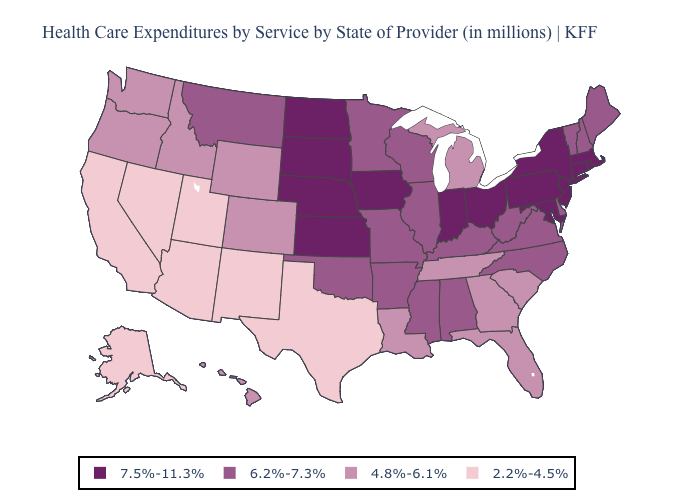Does New Mexico have a lower value than California?
Give a very brief answer. No. Name the states that have a value in the range 2.2%-4.5%?
Give a very brief answer. Alaska, Arizona, California, Nevada, New Mexico, Texas, Utah. Does Maine have a higher value than Montana?
Answer briefly. No. Does Nebraska have the highest value in the USA?
Give a very brief answer. Yes. Which states have the highest value in the USA?
Answer briefly. Connecticut, Indiana, Iowa, Kansas, Maryland, Massachusetts, Nebraska, New Jersey, New York, North Dakota, Ohio, Pennsylvania, Rhode Island, South Dakota. Name the states that have a value in the range 6.2%-7.3%?
Give a very brief answer. Alabama, Arkansas, Delaware, Illinois, Kentucky, Maine, Minnesota, Mississippi, Missouri, Montana, New Hampshire, North Carolina, Oklahoma, Vermont, Virginia, West Virginia, Wisconsin. What is the value of South Dakota?
Quick response, please. 7.5%-11.3%. Does New Hampshire have the same value as Illinois?
Give a very brief answer. Yes. Which states have the highest value in the USA?
Be succinct. Connecticut, Indiana, Iowa, Kansas, Maryland, Massachusetts, Nebraska, New Jersey, New York, North Dakota, Ohio, Pennsylvania, Rhode Island, South Dakota. Does Illinois have a lower value than Iowa?
Answer briefly. Yes. Among the states that border Nevada , does Idaho have the lowest value?
Keep it brief. No. Does Wisconsin have the lowest value in the MidWest?
Be succinct. No. What is the value of Washington?
Be succinct. 4.8%-6.1%. What is the lowest value in the USA?
Give a very brief answer. 2.2%-4.5%. Name the states that have a value in the range 4.8%-6.1%?
Write a very short answer. Colorado, Florida, Georgia, Hawaii, Idaho, Louisiana, Michigan, Oregon, South Carolina, Tennessee, Washington, Wyoming. 